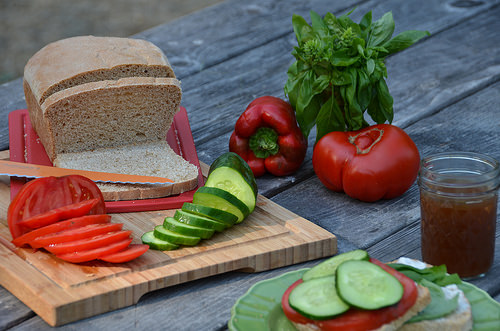<image>
Is the knife on the bread? Yes. Looking at the image, I can see the knife is positioned on top of the bread, with the bread providing support. 